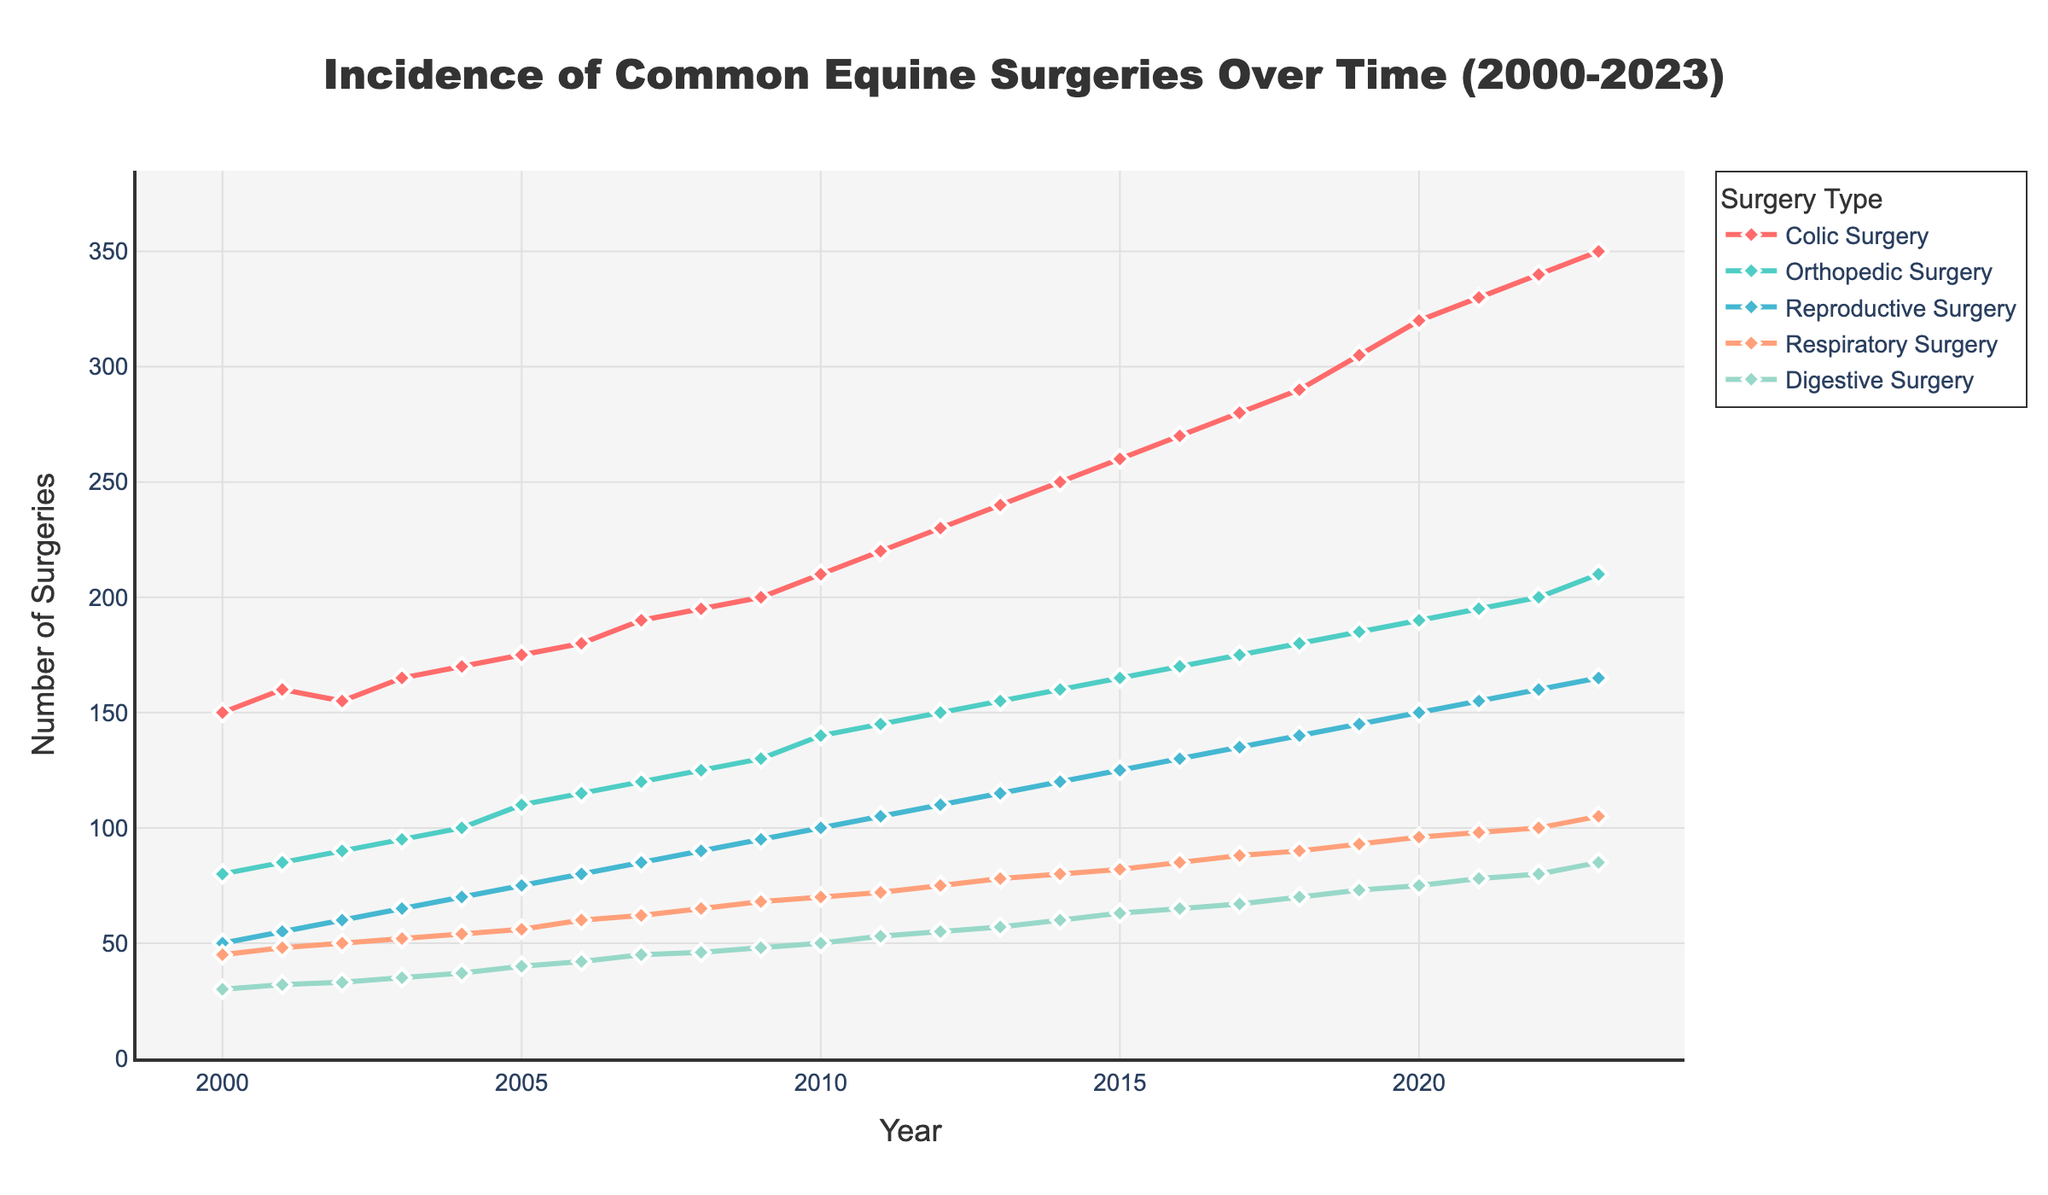What is the title of the figure? The title of the figure is displayed at the top and is a direct label.
Answer: Incidence of Common Equine Surgeries Over Time (2000-2023) How many types of surgeries are depicted in the figure? Count the number of unique surgery types listed in the legend.
Answer: 5 Which surgery type had the highest number of procedures in 2023? Look at the end of the time series for each surgery type in 2023 and identify the highest value.
Answer: Colic Surgery What is the trend for Orthopedic Surgery from 2000 to 2023? Examine the plotted line for Orthopedic Surgery from the beginning to the end of the time series.
Answer: Increasing How did the number of Reproductive Surgeries change between 2010 and 2020? Find the values for Reproductive Surgery in 2010 and 2020 and calculate the difference.
Answer: Increased by 50 What was the general trend for the number of Respiratory Surgeries over the 23-year period? Observe the shape of the plotted line for Respiratory Surgery from 2000 to 2023.
Answer: Gradual increase Which year saw the highest increase in Colic Surgeries compared to the previous year? Calculate the year-on-year difference for Colic Surgery and identify the largest increase.
Answer: 2020 How many surgeries of all types were performed in 2015? Sum the values of all surgery types for the year 2015.
Answer: 690 Were there any surgery types that exhibited a steady rise over the period? Analyze each of the plotted lines for constant upward trends from 2000 to 2023.
Answer: Yes, all types showed a steady rise Compare the increase rates of Colic Surgery and Digestive Surgery from 2010 to 2023. Calculate the difference between 2010 and 2023 values for both surgeries and compare these values.
Answer: Colic Surgery increased by 140, Digestive Surgery increased by 35 